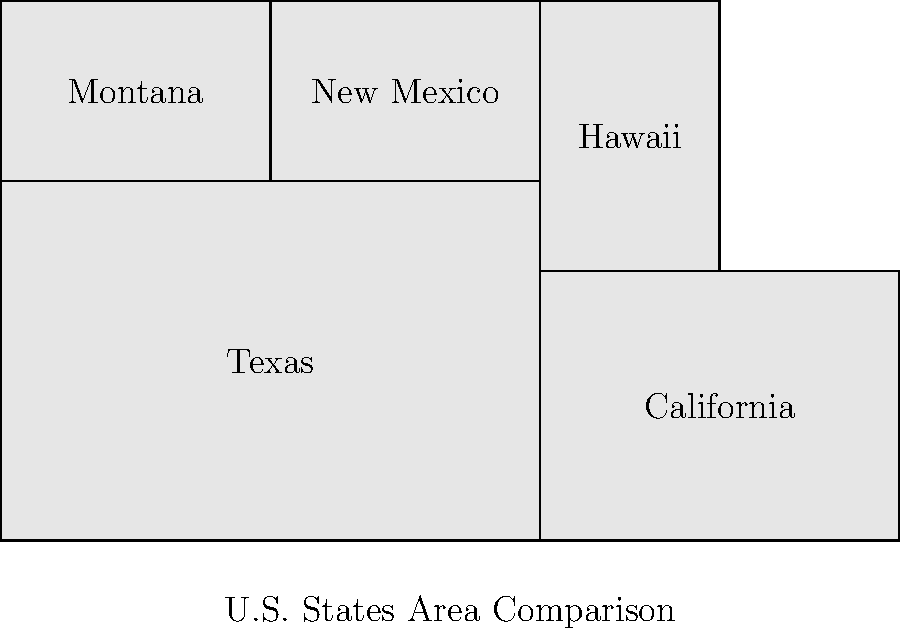In this infographic comparing U.S. state areas, Texas is represented by a 6x4 rectangle, while California is a 4x3 rectangle. If the area of Texas is 268,597 square miles, what is the approximate area of California based on this representation? To solve this problem, we'll follow these steps:

1. Calculate the area of the Texas rectangle:
   Area of Texas rectangle = $6 \times 4 = 24$ square units

2. Find the scale factor:
   Scale factor = $\frac{\text{Actual area of Texas}}{\text{Area of Texas rectangle}}$
   $= \frac{268,597}{24} = 11,191.54$ square miles per unit

3. Calculate the area of the California rectangle:
   Area of California rectangle = $4 \times 3 = 12$ square units

4. Use the scale factor to estimate California's area:
   Estimated area of California = $12 \times 11,191.54 = 134,298.48$ square miles

5. Round to the nearest thousand for a more headline-friendly number:
   $134,298.48 \approx 134,000$ square miles

This infographic provides a visually striking comparison of state sizes, allowing readers to quickly grasp relative areas. The actual area of California is about 163,696 square miles, so this representation is a reasonable approximation for a newspaper infographic.
Answer: 134,000 square miles 